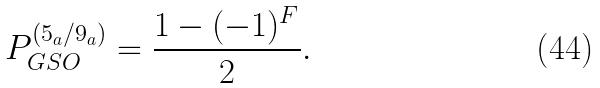Convert formula to latex. <formula><loc_0><loc_0><loc_500><loc_500>P _ { G S O } ^ { ( 5 _ { a } / 9 _ { a } ) } = \frac { 1 - ( - 1 ) ^ { F } } { 2 } .</formula> 